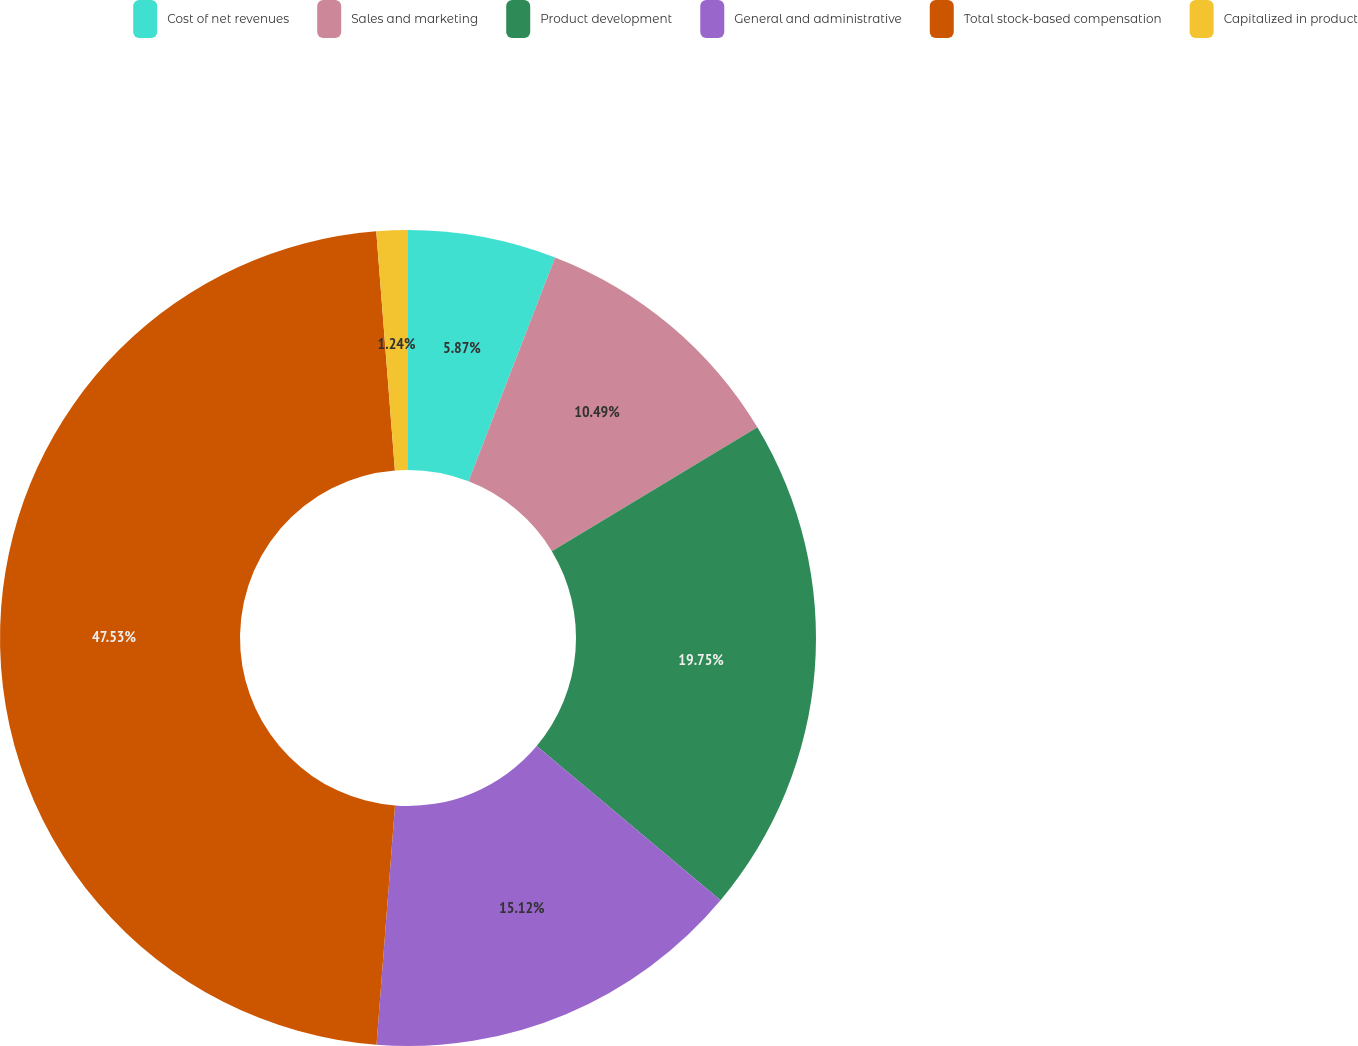Convert chart. <chart><loc_0><loc_0><loc_500><loc_500><pie_chart><fcel>Cost of net revenues<fcel>Sales and marketing<fcel>Product development<fcel>General and administrative<fcel>Total stock-based compensation<fcel>Capitalized in product<nl><fcel>5.87%<fcel>10.49%<fcel>19.75%<fcel>15.12%<fcel>47.53%<fcel>1.24%<nl></chart> 